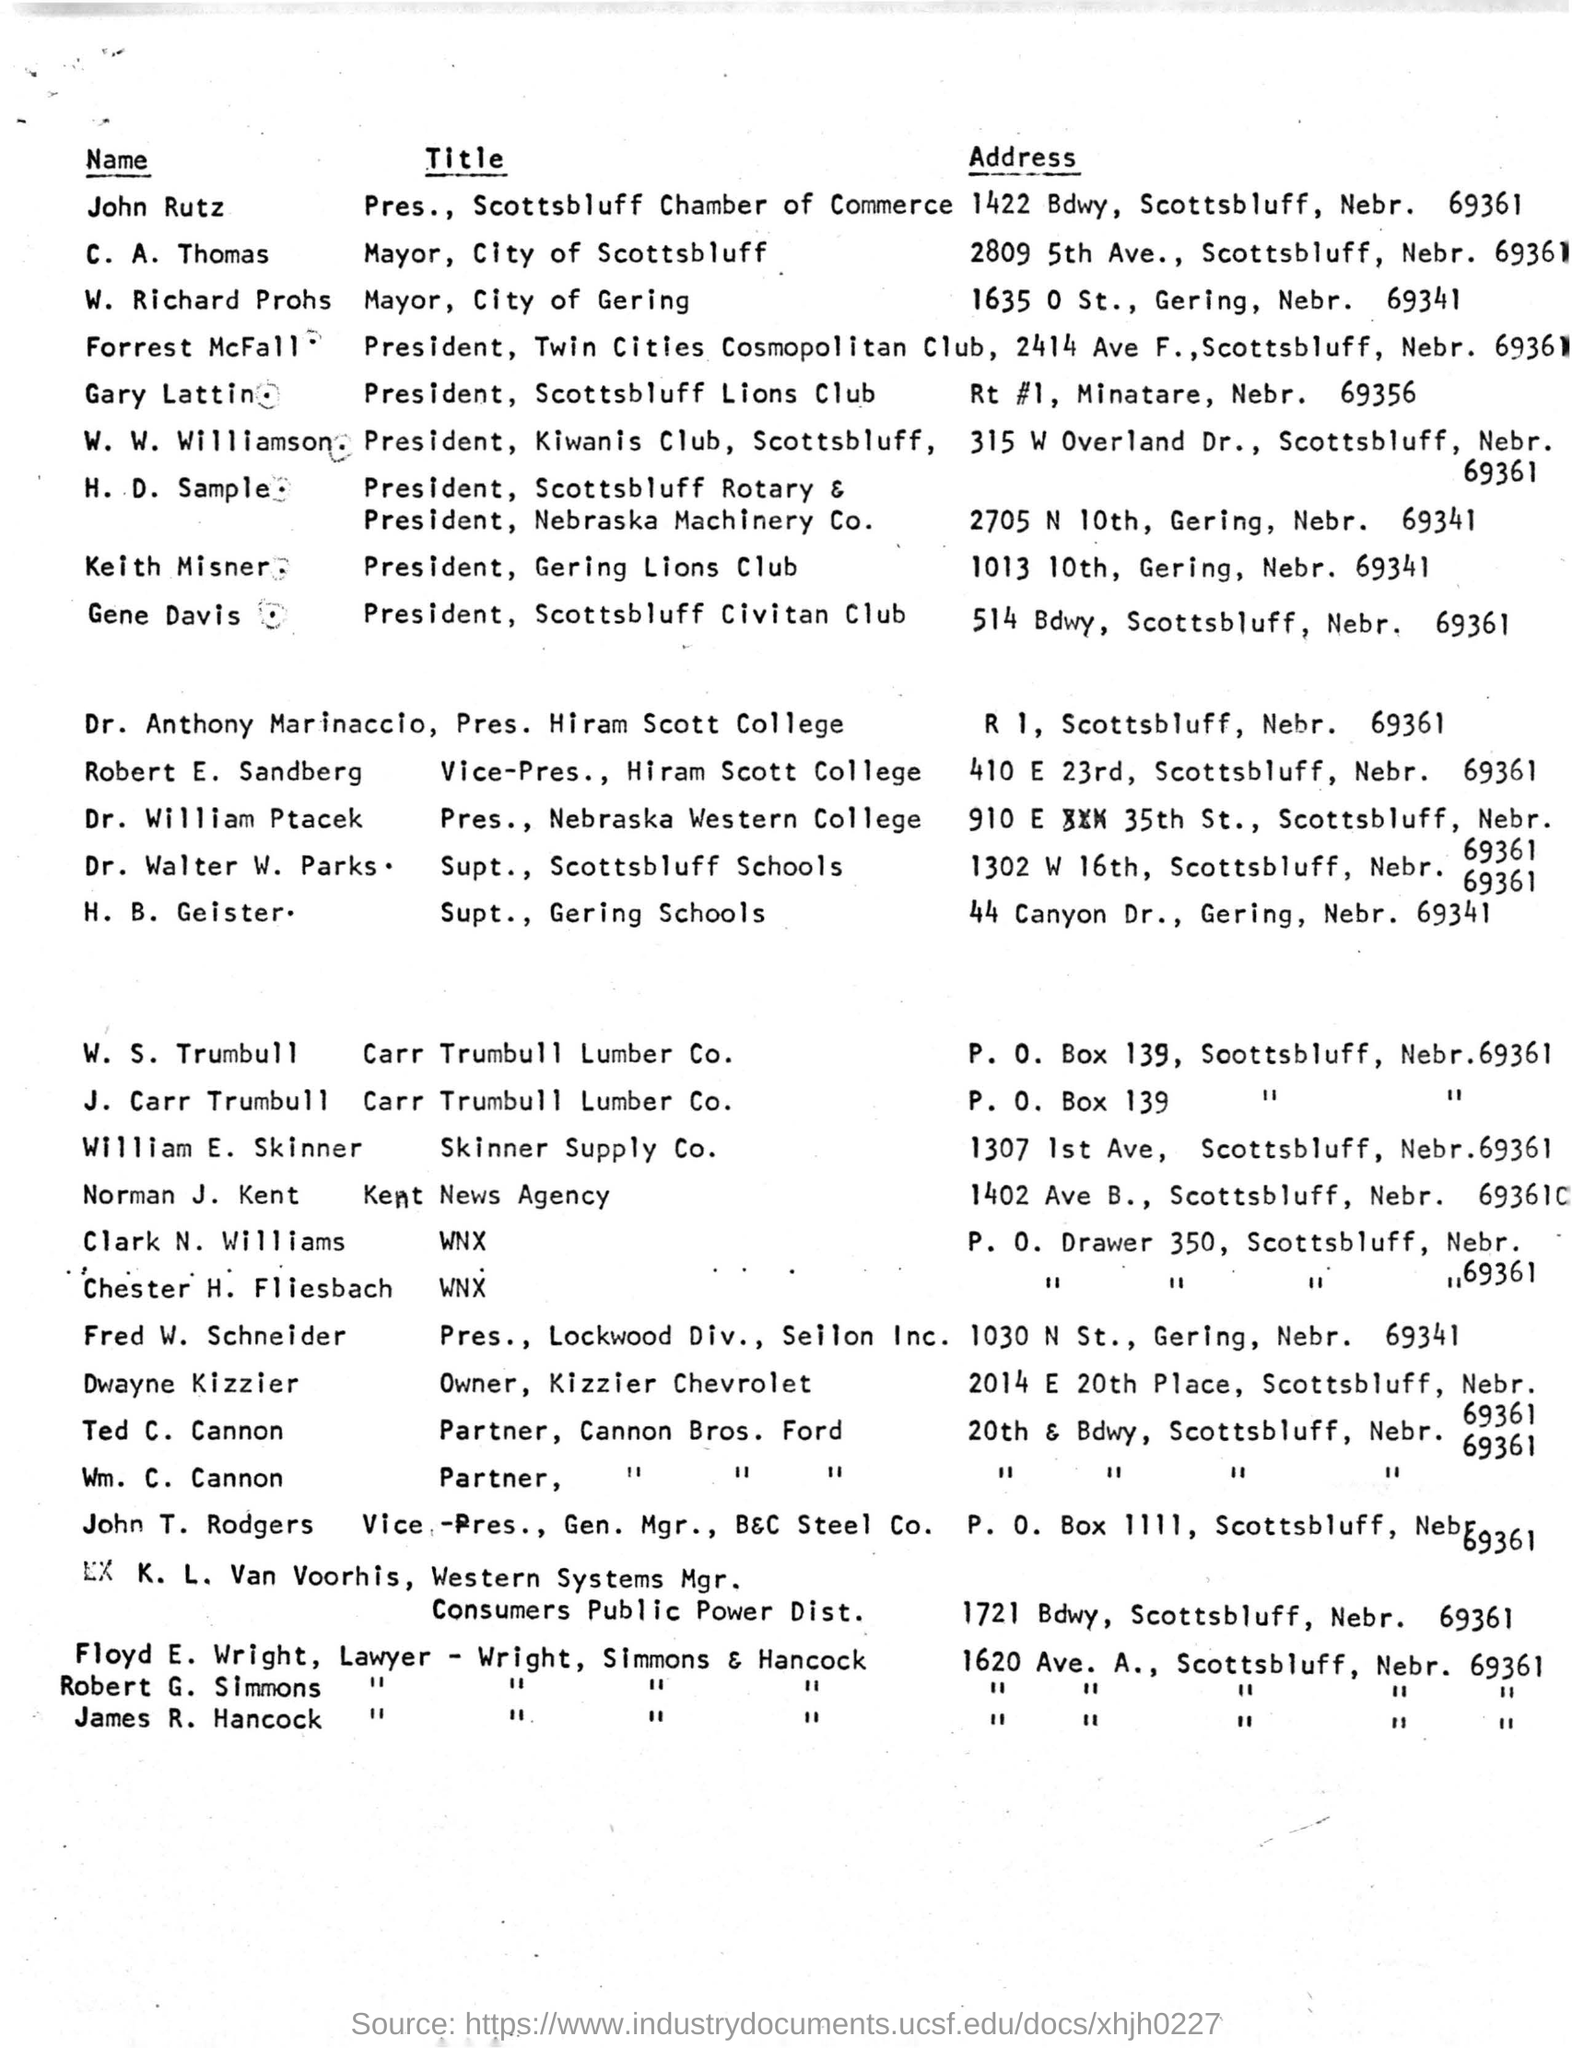Draw attention to some important aspects in this diagram. The address of H. B. Geister is 44 CANYON DR., GERING, NEBR. 69341. The title of Forrest Mcfall is President. The mayor of the city of Scottsbluff is C. A. THOMAS. 